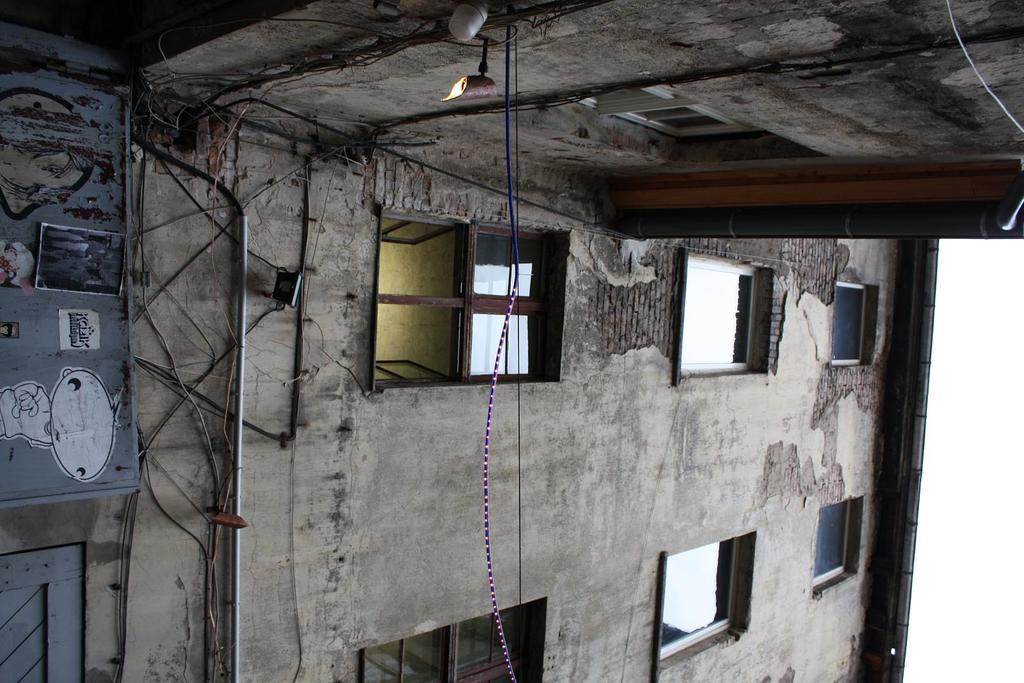What is located in the center of the image? There are buildings in the center of the image. What can be seen attached to or around the buildings? There are ropes visible in the image. What architectural features are present on the buildings? There are windows in the image. What is visible at the top of the image? The ceiling is visible at the top of the image. Can you see a stream of blood flowing from the windows in the image? No, there is no stream of blood visible in the image. 